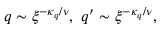Convert formula to latex. <formula><loc_0><loc_0><loc_500><loc_500>q \sim \xi ^ { - \kappa _ { q } / \nu } , \ q ^ { \prime } \sim \xi ^ { - \kappa _ { q } / \nu } ,</formula> 